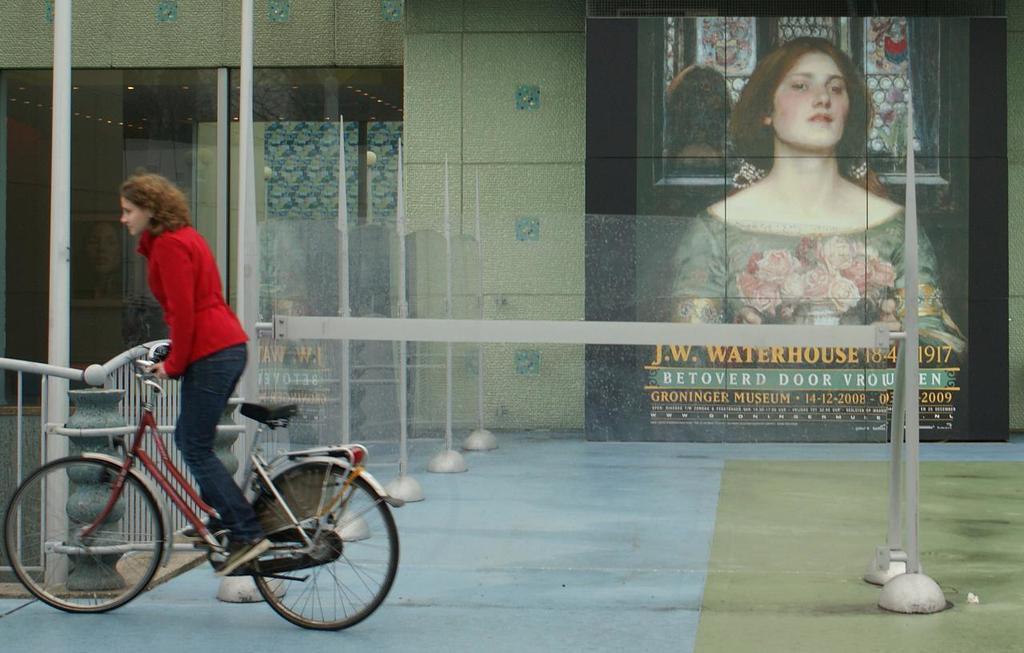Please provide a concise description of this image. Here we can see a woman riding a bicycle and beside her we can see a building there is a poster of a woman present 